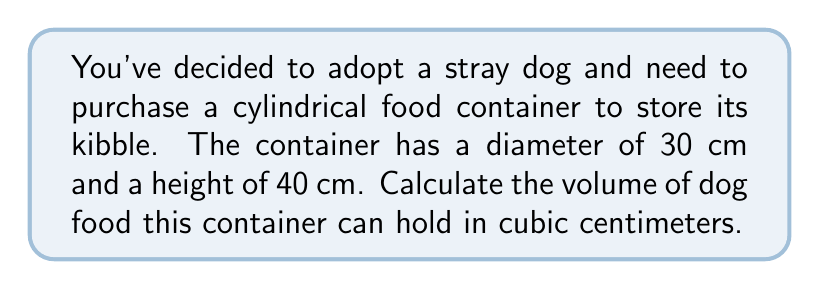Teach me how to tackle this problem. To find the volume of a cylindrical container, we need to use the formula for the volume of a cylinder:

$$V = \pi r^2 h$$

Where:
$V$ = volume
$r$ = radius of the base
$h$ = height of the cylinder

Let's solve this step-by-step:

1. Identify the given dimensions:
   Diameter = 30 cm
   Height = 40 cm

2. Calculate the radius:
   $r = \frac{\text{diameter}}{2} = \frac{30}{2} = 15$ cm

3. Substitute the values into the formula:
   $$V = \pi (15\text{ cm})^2 (40\text{ cm})$$

4. Simplify:
   $$V = \pi (225\text{ cm}^2) (40\text{ cm})$$
   $$V = 9000\pi\text{ cm}^3$$

5. Calculate the final result:
   $$V \approx 28,274.33\text{ cm}^3$$

Therefore, the cylindrical food container can hold approximately 28,274.33 cubic centimeters of dog food.
Answer: $28,274.33\text{ cm}^3$ 